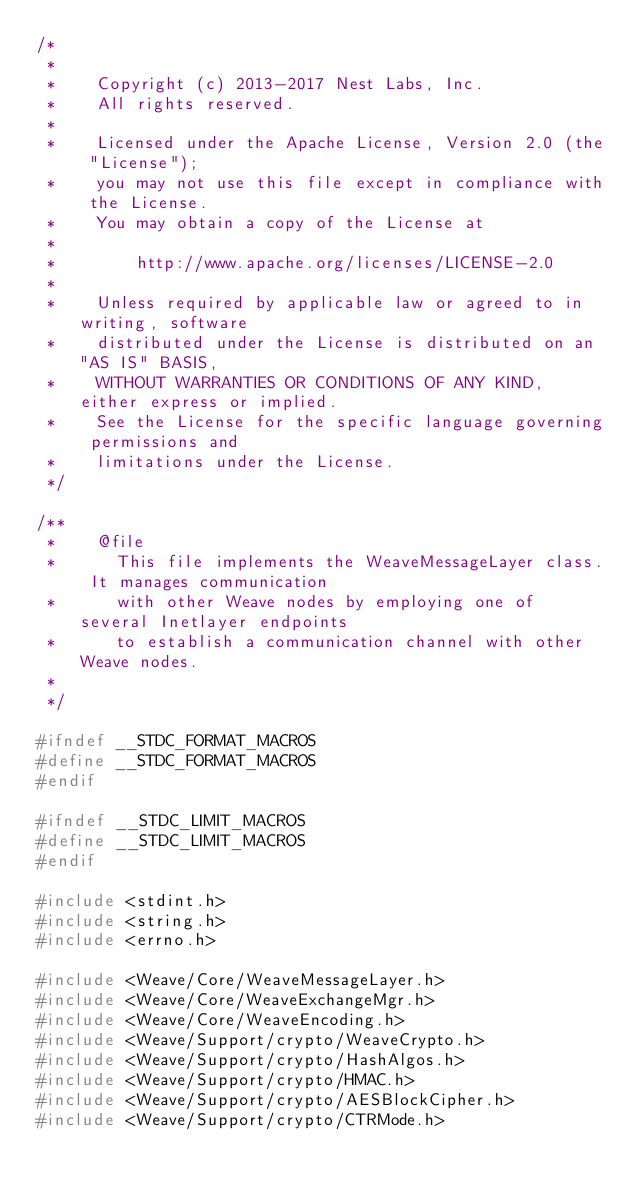Convert code to text. <code><loc_0><loc_0><loc_500><loc_500><_C++_>/*
 *
 *    Copyright (c) 2013-2017 Nest Labs, Inc.
 *    All rights reserved.
 *
 *    Licensed under the Apache License, Version 2.0 (the "License");
 *    you may not use this file except in compliance with the License.
 *    You may obtain a copy of the License at
 *
 *        http://www.apache.org/licenses/LICENSE-2.0
 *
 *    Unless required by applicable law or agreed to in writing, software
 *    distributed under the License is distributed on an "AS IS" BASIS,
 *    WITHOUT WARRANTIES OR CONDITIONS OF ANY KIND, either express or implied.
 *    See the License for the specific language governing permissions and
 *    limitations under the License.
 */

/**
 *    @file
 *      This file implements the WeaveMessageLayer class. It manages communication
 *      with other Weave nodes by employing one of several Inetlayer endpoints
 *      to establish a communication channel with other Weave nodes.
 *
 */

#ifndef __STDC_FORMAT_MACROS
#define __STDC_FORMAT_MACROS
#endif

#ifndef __STDC_LIMIT_MACROS
#define __STDC_LIMIT_MACROS
#endif

#include <stdint.h>
#include <string.h>
#include <errno.h>

#include <Weave/Core/WeaveMessageLayer.h>
#include <Weave/Core/WeaveExchangeMgr.h>
#include <Weave/Core/WeaveEncoding.h>
#include <Weave/Support/crypto/WeaveCrypto.h>
#include <Weave/Support/crypto/HashAlgos.h>
#include <Weave/Support/crypto/HMAC.h>
#include <Weave/Support/crypto/AESBlockCipher.h>
#include <Weave/Support/crypto/CTRMode.h></code> 